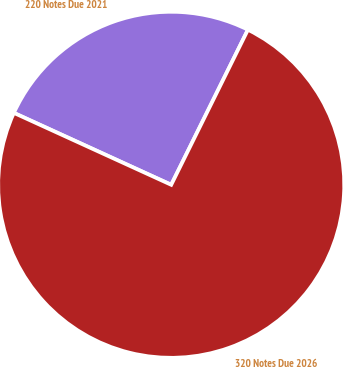Convert chart to OTSL. <chart><loc_0><loc_0><loc_500><loc_500><pie_chart><fcel>220 Notes Due 2021<fcel>320 Notes Due 2026<nl><fcel>25.49%<fcel>74.51%<nl></chart> 